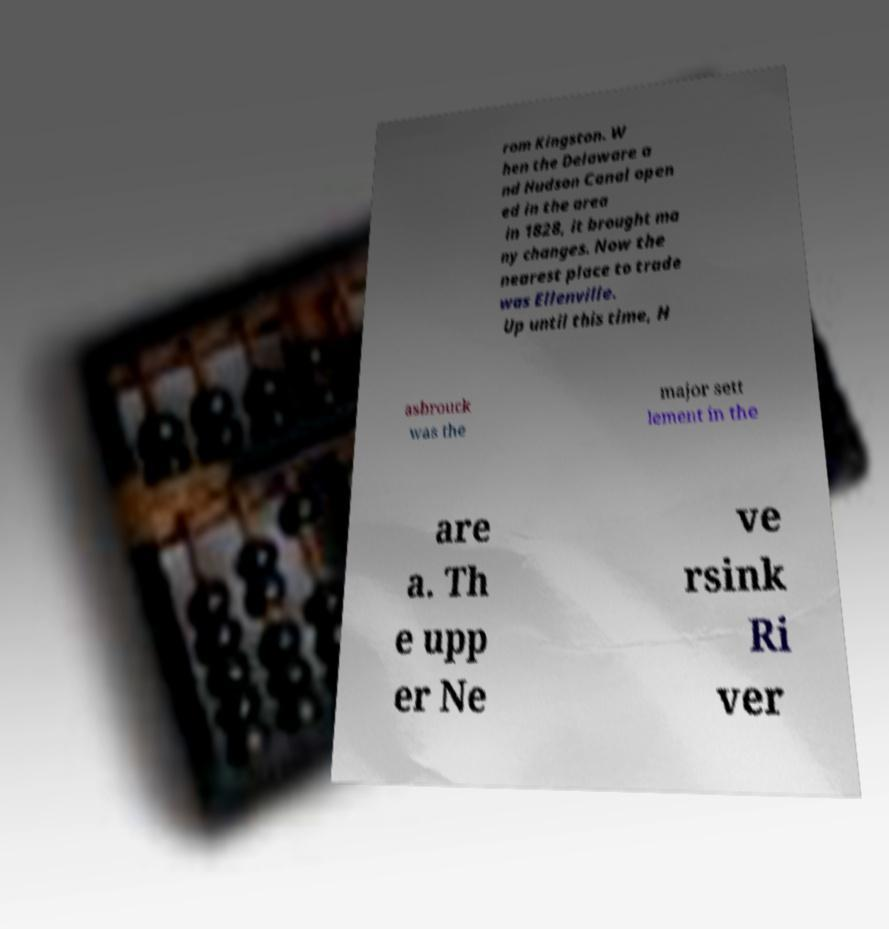There's text embedded in this image that I need extracted. Can you transcribe it verbatim? rom Kingston. W hen the Delaware a nd Hudson Canal open ed in the area in 1828, it brought ma ny changes. Now the nearest place to trade was Ellenville. Up until this time, H asbrouck was the major sett lement in the are a. Th e upp er Ne ve rsink Ri ver 